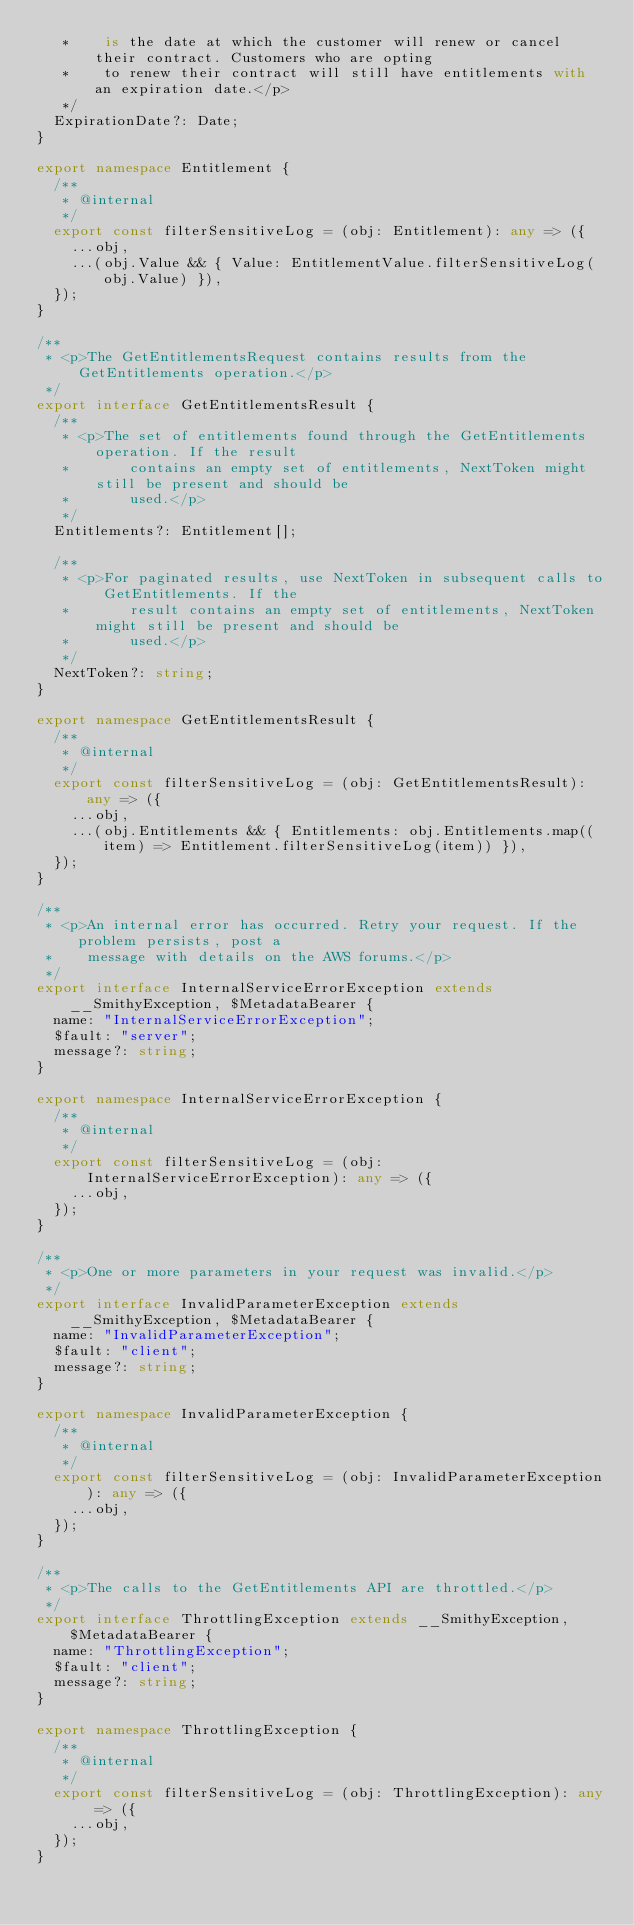Convert code to text. <code><loc_0><loc_0><loc_500><loc_500><_TypeScript_>   *    is the date at which the customer will renew or cancel their contract. Customers who are opting
   *    to renew their contract will still have entitlements with an expiration date.</p>
   */
  ExpirationDate?: Date;
}

export namespace Entitlement {
  /**
   * @internal
   */
  export const filterSensitiveLog = (obj: Entitlement): any => ({
    ...obj,
    ...(obj.Value && { Value: EntitlementValue.filterSensitiveLog(obj.Value) }),
  });
}

/**
 * <p>The GetEntitlementsRequest contains results from the GetEntitlements operation.</p>
 */
export interface GetEntitlementsResult {
  /**
   * <p>The set of entitlements found through the GetEntitlements operation. If the result
   *       contains an empty set of entitlements, NextToken might still be present and should be
   *       used.</p>
   */
  Entitlements?: Entitlement[];

  /**
   * <p>For paginated results, use NextToken in subsequent calls to GetEntitlements. If the
   *       result contains an empty set of entitlements, NextToken might still be present and should be
   *       used.</p>
   */
  NextToken?: string;
}

export namespace GetEntitlementsResult {
  /**
   * @internal
   */
  export const filterSensitiveLog = (obj: GetEntitlementsResult): any => ({
    ...obj,
    ...(obj.Entitlements && { Entitlements: obj.Entitlements.map((item) => Entitlement.filterSensitiveLog(item)) }),
  });
}

/**
 * <p>An internal error has occurred. Retry your request. If the problem persists, post a
 *    message with details on the AWS forums.</p>
 */
export interface InternalServiceErrorException extends __SmithyException, $MetadataBearer {
  name: "InternalServiceErrorException";
  $fault: "server";
  message?: string;
}

export namespace InternalServiceErrorException {
  /**
   * @internal
   */
  export const filterSensitiveLog = (obj: InternalServiceErrorException): any => ({
    ...obj,
  });
}

/**
 * <p>One or more parameters in your request was invalid.</p>
 */
export interface InvalidParameterException extends __SmithyException, $MetadataBearer {
  name: "InvalidParameterException";
  $fault: "client";
  message?: string;
}

export namespace InvalidParameterException {
  /**
   * @internal
   */
  export const filterSensitiveLog = (obj: InvalidParameterException): any => ({
    ...obj,
  });
}

/**
 * <p>The calls to the GetEntitlements API are throttled.</p>
 */
export interface ThrottlingException extends __SmithyException, $MetadataBearer {
  name: "ThrottlingException";
  $fault: "client";
  message?: string;
}

export namespace ThrottlingException {
  /**
   * @internal
   */
  export const filterSensitiveLog = (obj: ThrottlingException): any => ({
    ...obj,
  });
}
</code> 